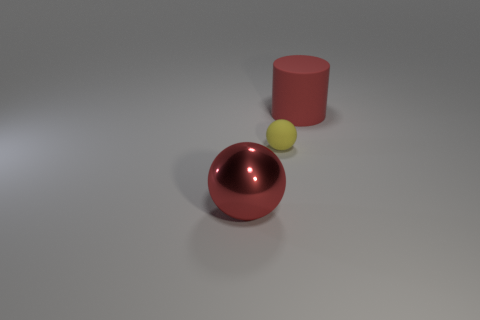Are there any other things that are the same size as the yellow sphere?
Your answer should be very brief. No. There is a large red object that is left of the small rubber ball; does it have the same shape as the matte object that is left of the large red matte thing?
Provide a short and direct response. Yes. There is a matte object in front of the red cylinder; what is its color?
Provide a succinct answer. Yellow. Are there fewer cylinders left of the big red metallic thing than yellow matte things that are in front of the matte sphere?
Provide a short and direct response. No. How many other things are the same material as the yellow thing?
Provide a succinct answer. 1. Is the tiny object made of the same material as the big red sphere?
Ensure brevity in your answer.  No. What number of other things are there of the same size as the red matte cylinder?
Your response must be concise. 1. What size is the matte ball that is to the right of the big red thing on the left side of the matte ball?
Provide a short and direct response. Small. There is a tiny rubber object that is on the left side of the big red cylinder that is to the right of the large metallic thing in front of the big red cylinder; what color is it?
Provide a succinct answer. Yellow. How many other objects are there of the same shape as the tiny object?
Keep it short and to the point. 1. 